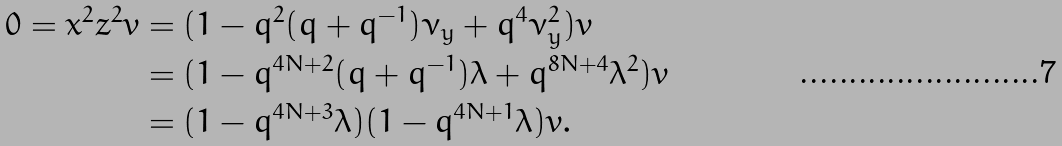Convert formula to latex. <formula><loc_0><loc_0><loc_500><loc_500>0 = x ^ { 2 } z ^ { 2 } v & = ( 1 - q ^ { 2 } ( q + q ^ { - 1 } ) \nu _ { y } + q ^ { 4 } \nu _ { y } ^ { 2 } ) v \\ & = ( 1 - q ^ { 4 N + 2 } ( q + q ^ { - 1 } ) \lambda + q ^ { 8 N + 4 } \lambda ^ { 2 } ) v \\ & = ( 1 - q ^ { 4 N + 3 } \lambda ) ( 1 - q ^ { 4 N + 1 } \lambda ) v .</formula> 